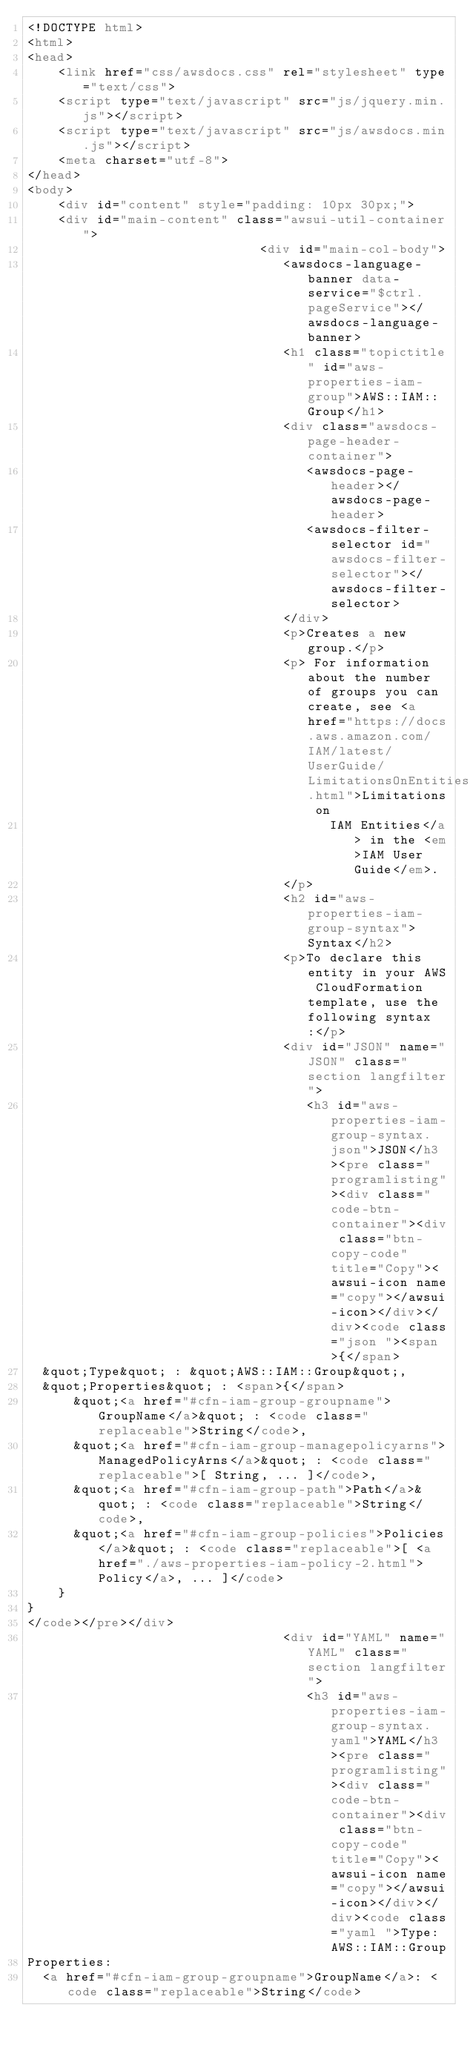Convert code to text. <code><loc_0><loc_0><loc_500><loc_500><_HTML_><!DOCTYPE html>
<html>
<head>
    <link href="css/awsdocs.css" rel="stylesheet" type="text/css">
    <script type="text/javascript" src="js/jquery.min.js"></script>
    <script type="text/javascript" src="js/awsdocs.min.js"></script>
    <meta charset="utf-8">
</head>
<body>
    <div id="content" style="padding: 10px 30px;">
    <div id="main-content" class="awsui-util-container">
                              <div id="main-col-body">
                                 <awsdocs-language-banner data-service="$ctrl.pageService"></awsdocs-language-banner>
                                 <h1 class="topictitle" id="aws-properties-iam-group">AWS::IAM::Group</h1>
                                 <div class="awsdocs-page-header-container">
                                    <awsdocs-page-header></awsdocs-page-header>
                                    <awsdocs-filter-selector id="awsdocs-filter-selector"></awsdocs-filter-selector>
                                 </div>
                                 <p>Creates a new group.</p>
                                 <p> For information about the number of groups you can create, see <a href="https://docs.aws.amazon.com/IAM/latest/UserGuide/LimitationsOnEntities.html">Limitations on
                                       IAM Entities</a> in the <em>IAM User Guide</em>.
                                 </p>
                                 <h2 id="aws-properties-iam-group-syntax">Syntax</h2>
                                 <p>To declare this entity in your AWS CloudFormation template, use the following syntax:</p>
                                 <div id="JSON" name="JSON" class="section langfilter">
                                    <h3 id="aws-properties-iam-group-syntax.json">JSON</h3><pre class="programlisting"><div class="code-btn-container"><div class="btn-copy-code" title="Copy"><awsui-icon name="copy"></awsui-icon></div></div><code class="json "><span>{</span>
  &quot;Type&quot; : &quot;AWS::IAM::Group&quot;,
  &quot;Properties&quot; : <span>{</span>
      &quot;<a href="#cfn-iam-group-groupname">GroupName</a>&quot; : <code class="replaceable">String</code>,
      &quot;<a href="#cfn-iam-group-managepolicyarns">ManagedPolicyArns</a>&quot; : <code class="replaceable">[ String, ... ]</code>,
      &quot;<a href="#cfn-iam-group-path">Path</a>&quot; : <code class="replaceable">String</code>,
      &quot;<a href="#cfn-iam-group-policies">Policies</a>&quot; : <code class="replaceable">[ <a href="./aws-properties-iam-policy-2.html">Policy</a>, ... ]</code>
    }
}
</code></pre></div>
                                 <div id="YAML" name="YAML" class="section langfilter">
                                    <h3 id="aws-properties-iam-group-syntax.yaml">YAML</h3><pre class="programlisting"><div class="code-btn-container"><div class="btn-copy-code" title="Copy"><awsui-icon name="copy"></awsui-icon></div></div><code class="yaml ">Type: AWS::IAM::Group
Properties: 
  <a href="#cfn-iam-group-groupname">GroupName</a>: <code class="replaceable">String</code></code> 